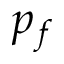Convert formula to latex. <formula><loc_0><loc_0><loc_500><loc_500>p _ { f }</formula> 